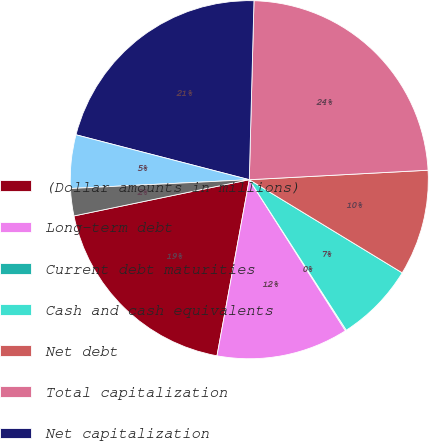Convert chart. <chart><loc_0><loc_0><loc_500><loc_500><pie_chart><fcel>(Dollar amounts in millions)<fcel>Long-term debt<fcel>Current debt maturities<fcel>Cash and cash equivalents<fcel>Net debt<fcel>Total capitalization<fcel>Net capitalization<fcel>Long-term debt to total<fcel>Net debt to net capitalization<nl><fcel>18.87%<fcel>11.91%<fcel>0.09%<fcel>7.18%<fcel>9.55%<fcel>23.74%<fcel>21.38%<fcel>4.82%<fcel>2.46%<nl></chart> 